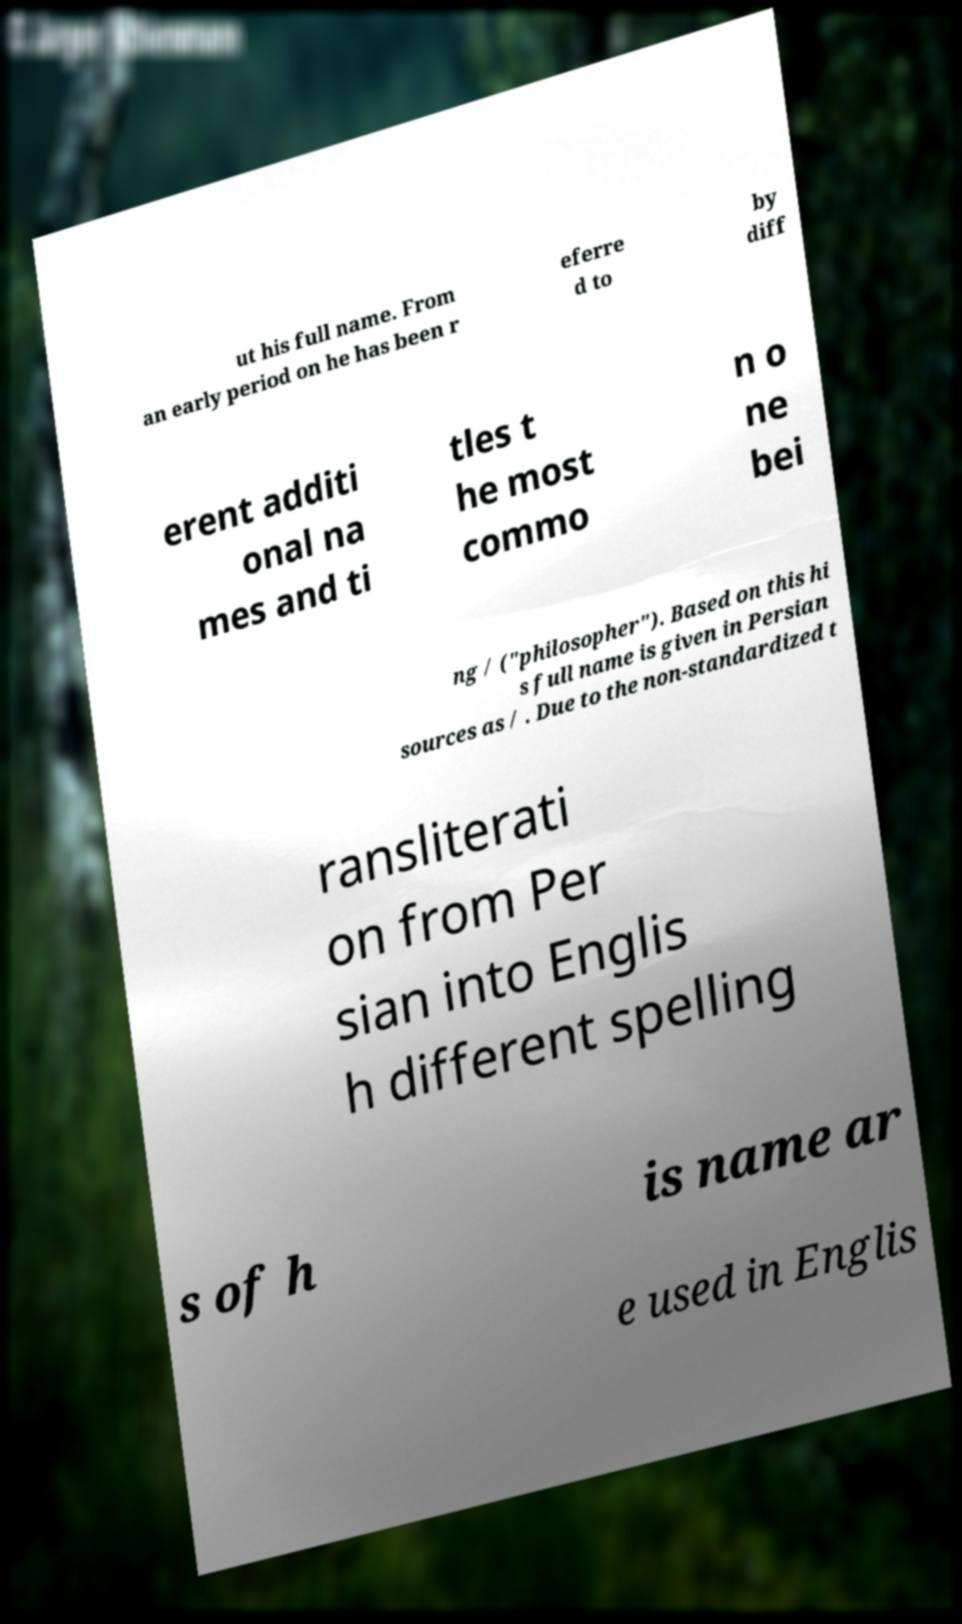Please identify and transcribe the text found in this image. ut his full name. From an early period on he has been r eferre d to by diff erent additi onal na mes and ti tles t he most commo n o ne bei ng / ("philosopher"). Based on this hi s full name is given in Persian sources as / . Due to the non-standardized t ransliterati on from Per sian into Englis h different spelling s of h is name ar e used in Englis 